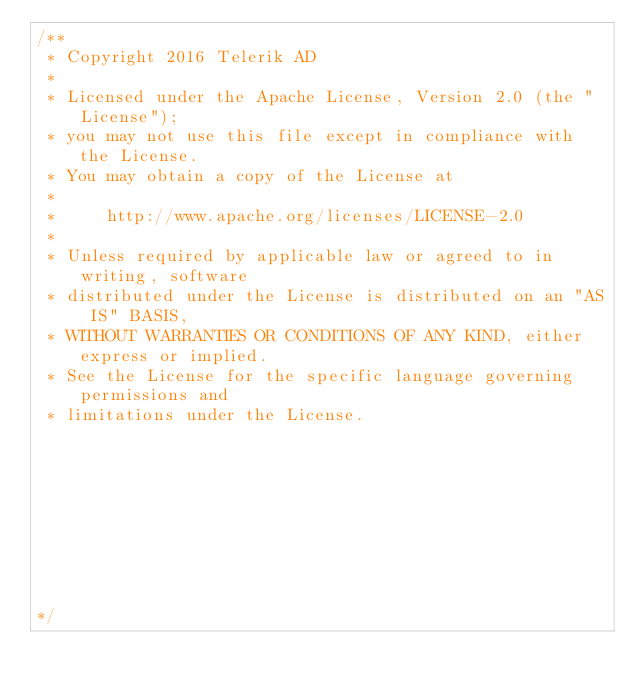<code> <loc_0><loc_0><loc_500><loc_500><_JavaScript_>/** 
 * Copyright 2016 Telerik AD                                                                                                                                                                            
 *                                                                                                                                                                                                      
 * Licensed under the Apache License, Version 2.0 (the "License");                                                                                                                                      
 * you may not use this file except in compliance with the License.                                                                                                                                     
 * You may obtain a copy of the License at                                                                                                                                                              
 *                                                                                                                                                                                                      
 *     http://www.apache.org/licenses/LICENSE-2.0                                                                                                                                                       
 *                                                                                                                                                                                                      
 * Unless required by applicable law or agreed to in writing, software                                                                                                                                  
 * distributed under the License is distributed on an "AS IS" BASIS,                                                                                                                                    
 * WITHOUT WARRANTIES OR CONDITIONS OF ANY KIND, either express or implied.                                                                                                                             
 * See the License for the specific language governing permissions and                                                                                                                                  
 * limitations under the License.                                                                                                                                                                       
                                                                                                                                                                                                       
                                                                                                                                                                                                       
                                                                                                                                                                                                       
                                                                                                                                                                                                       
                                                                                                                                                                                                       
                                                                                                                                                                                                       
                                                                                                                                                                                                       
                                                                                                                                                                                                       

*/</code> 